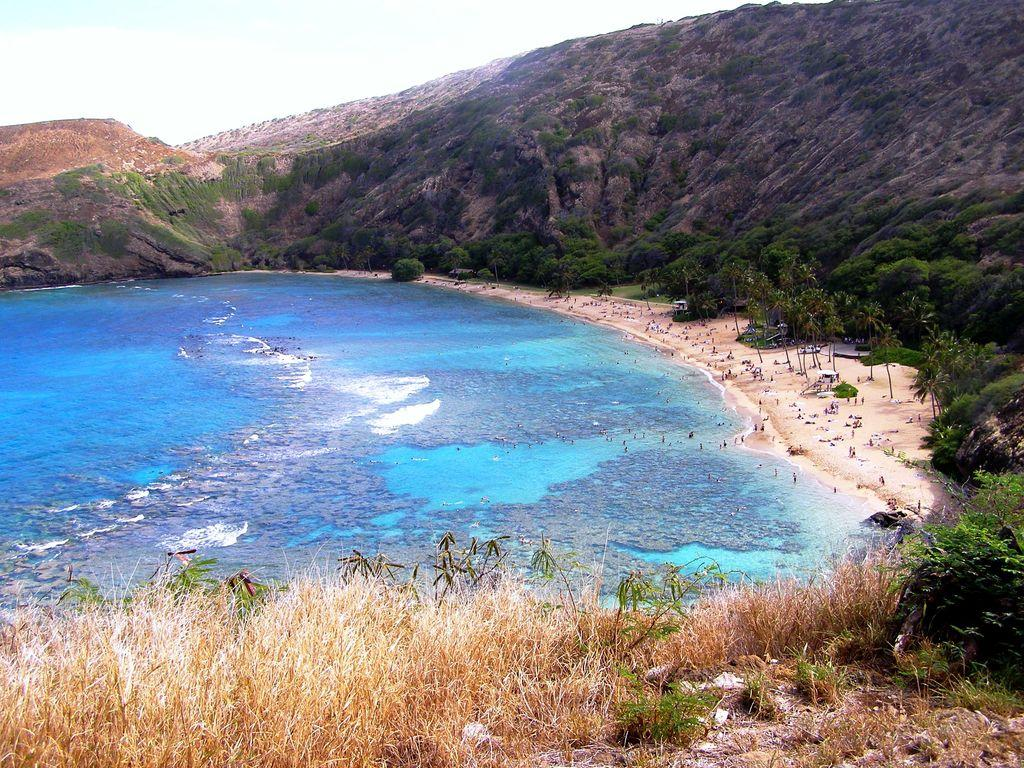How many people are present in the image? There is a group of people in the image. What is the natural element visible in the image? Water is visible in the image. What type of vegetation can be seen in the image? Plants and trees are present in the image. What geographical feature is visible in the image? Hills are visible in the image. What is visible in the background of the image? The sky is visible in the background of the image. What type of dolls are placed on the territory in the image? There are no dolls or territory present in the image. What type of cemetery can be seen in the image? There is no cemetery present in the image. 